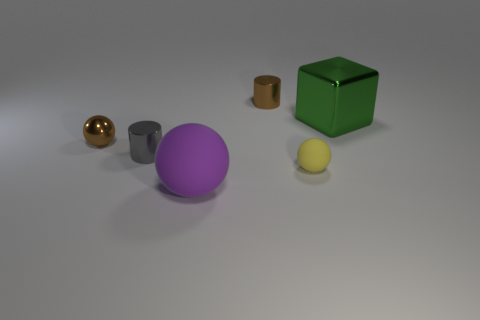Subtract 1 balls. How many balls are left? 2 Add 3 yellow metal blocks. How many objects exist? 9 Subtract all cylinders. How many objects are left? 4 Add 5 brown objects. How many brown objects exist? 7 Subtract 0 green cylinders. How many objects are left? 6 Subtract all large yellow metal cubes. Subtract all tiny balls. How many objects are left? 4 Add 5 small brown shiny cylinders. How many small brown shiny cylinders are left? 6 